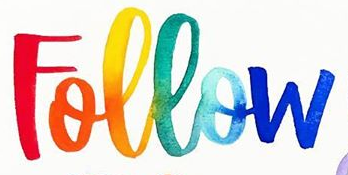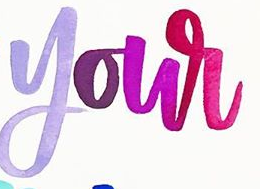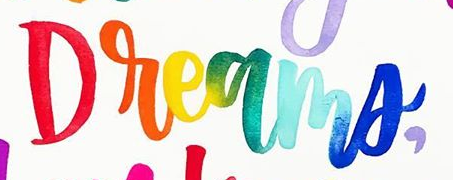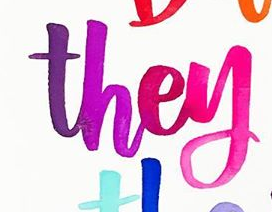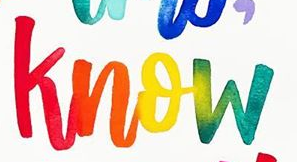What words can you see in these images in sequence, separated by a semicolon? Follow; your; Dreams,; they; know 